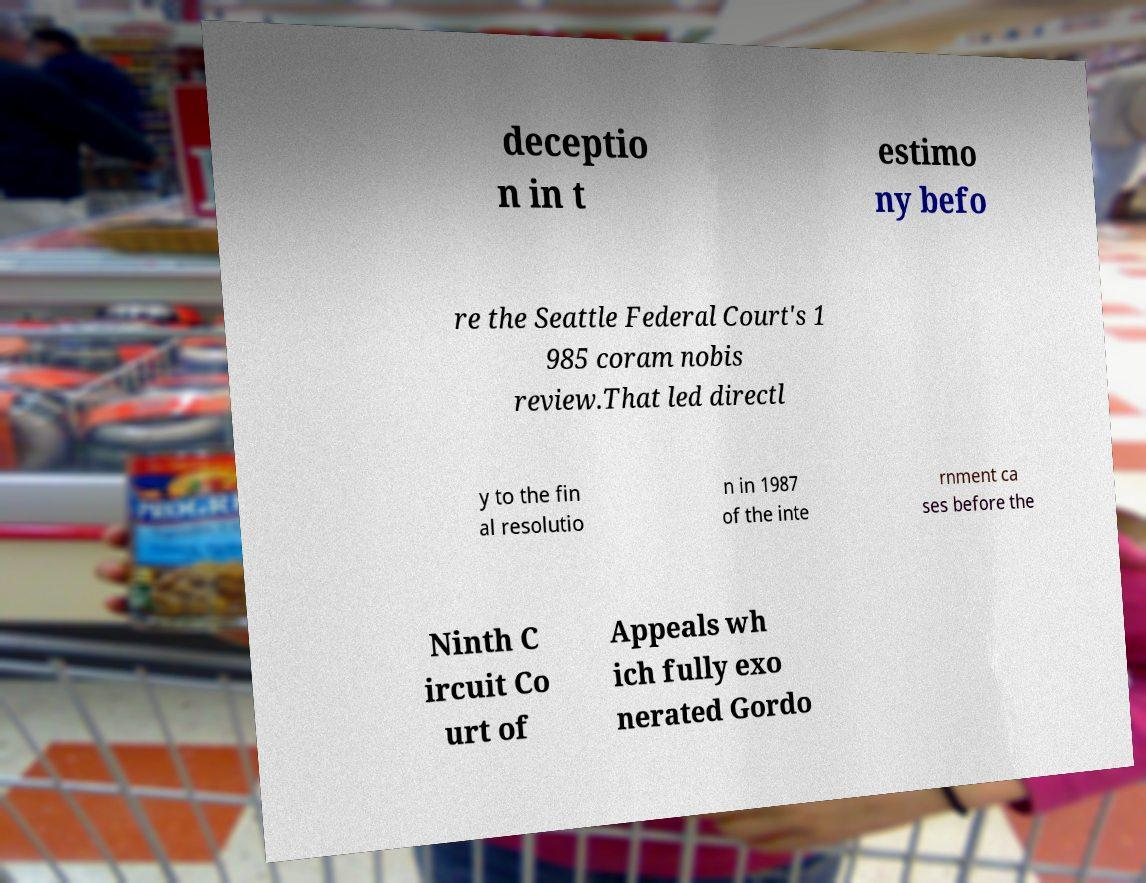There's text embedded in this image that I need extracted. Can you transcribe it verbatim? deceptio n in t estimo ny befo re the Seattle Federal Court's 1 985 coram nobis review.That led directl y to the fin al resolutio n in 1987 of the inte rnment ca ses before the Ninth C ircuit Co urt of Appeals wh ich fully exo nerated Gordo 